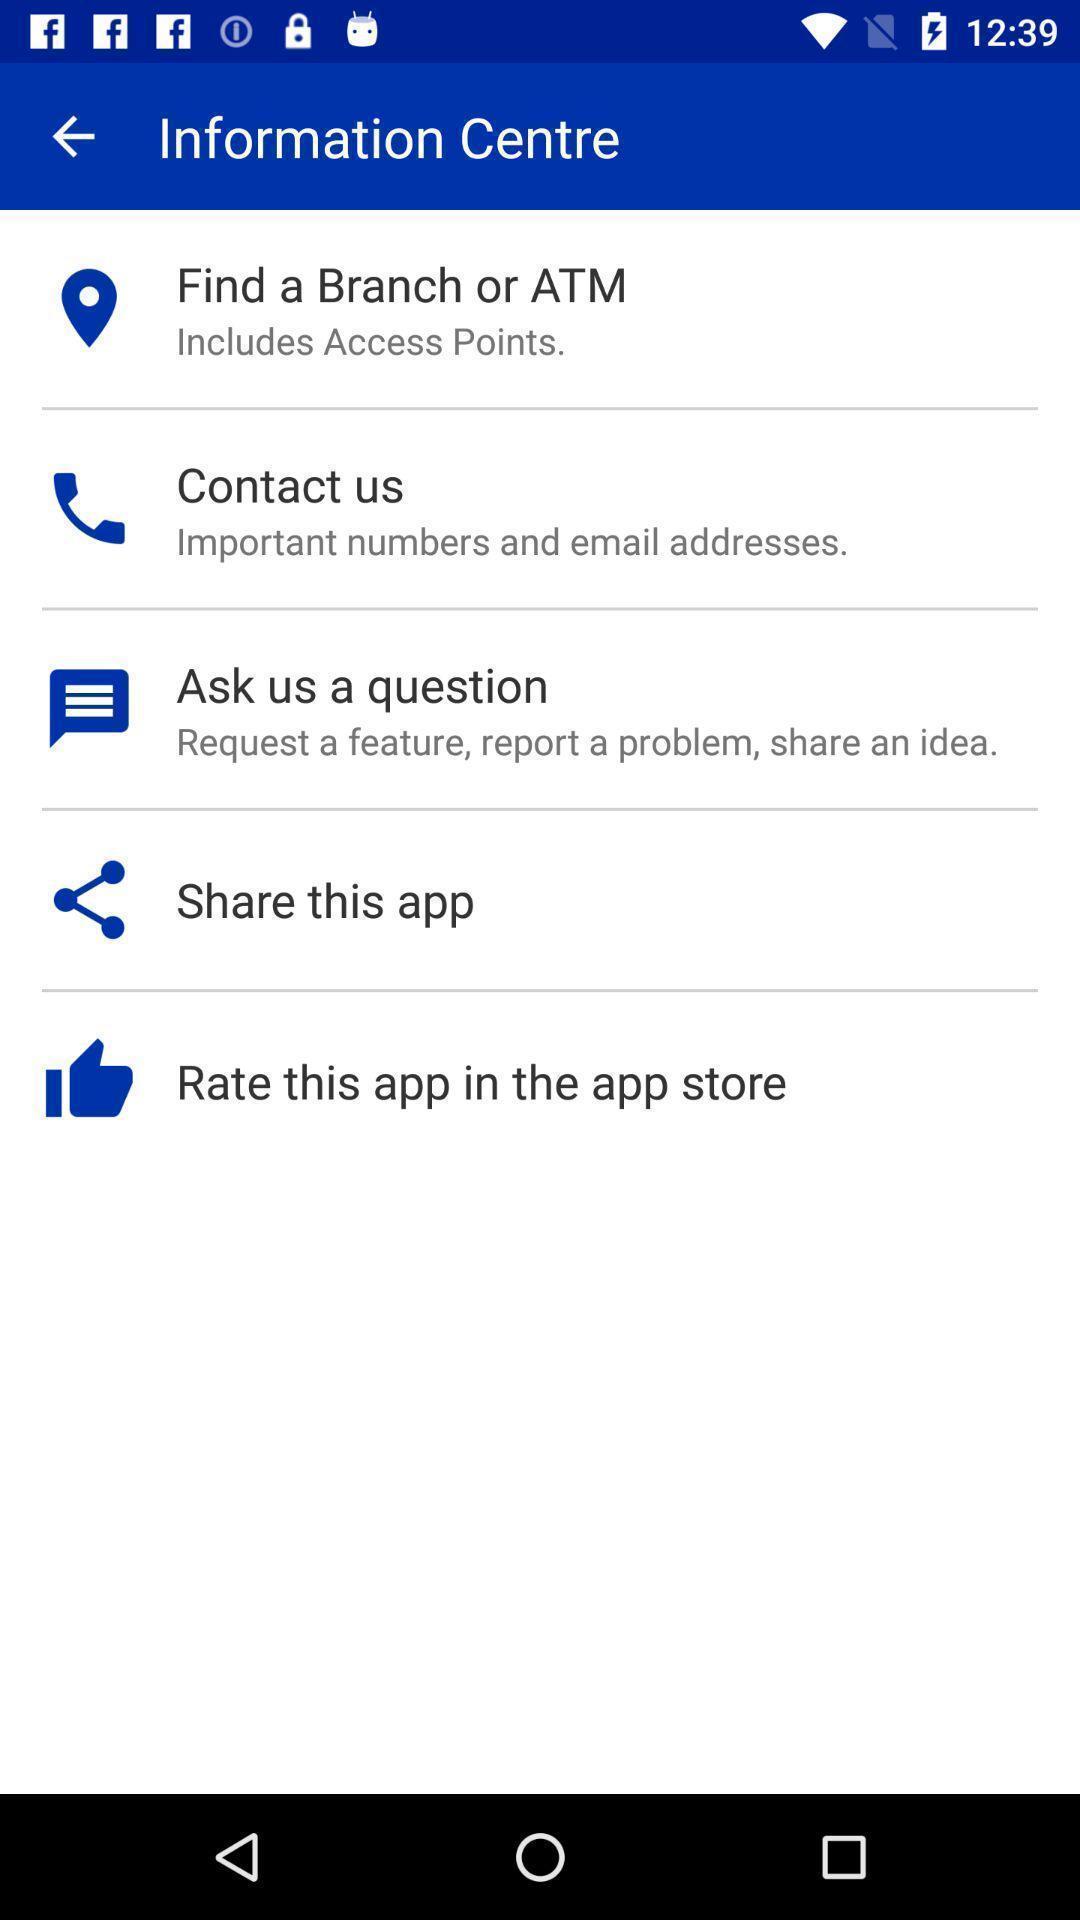Describe the content in this image. Screen displaying multiple options with icons. 